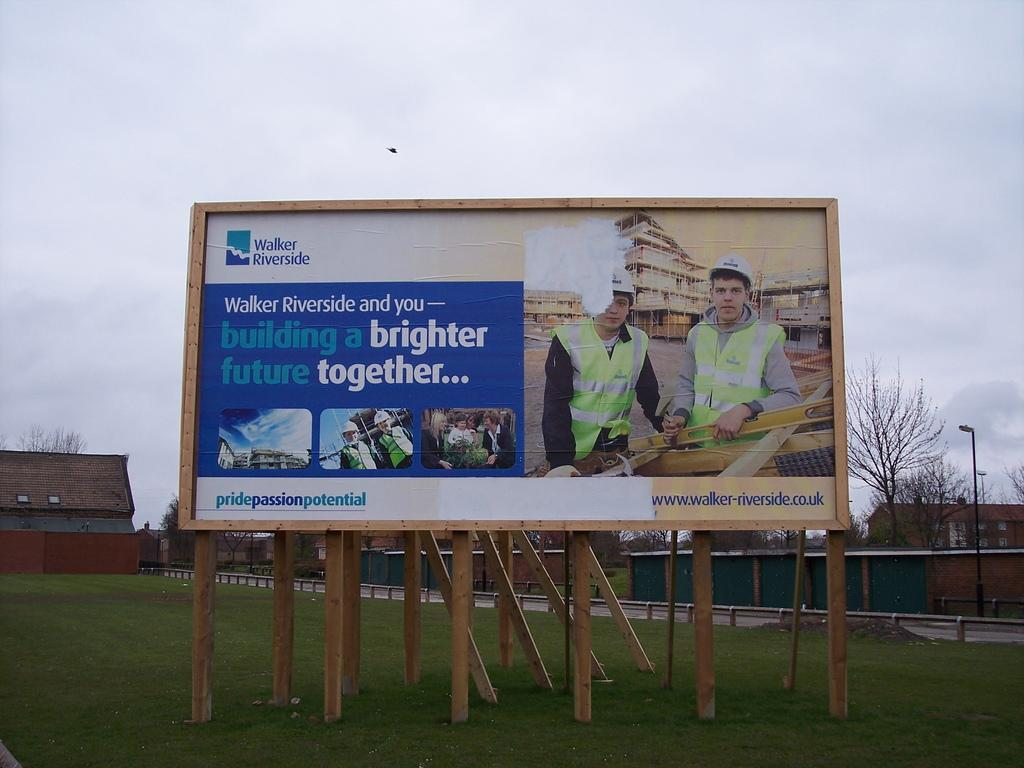Provide a one-sentence caption for the provided image. A billboard from Walker Riverside shows two construction workers. 